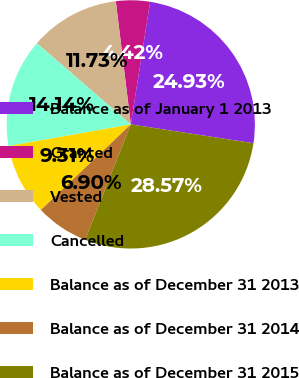Convert chart to OTSL. <chart><loc_0><loc_0><loc_500><loc_500><pie_chart><fcel>Balance as of January 1 2013<fcel>Granted<fcel>Vested<fcel>Cancelled<fcel>Balance as of December 31 2013<fcel>Balance as of December 31 2014<fcel>Balance as of December 31 2015<nl><fcel>24.93%<fcel>4.42%<fcel>11.73%<fcel>14.14%<fcel>9.31%<fcel>6.9%<fcel>28.57%<nl></chart> 